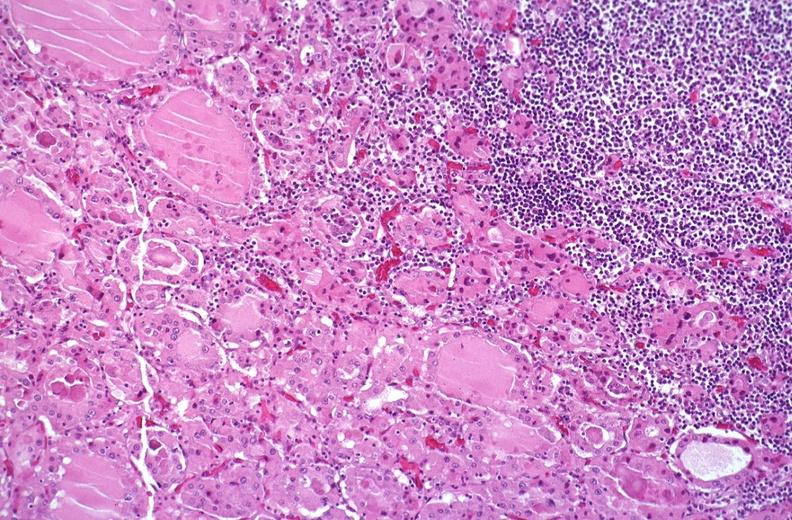what is present?
Answer the question using a single word or phrase. Endocrine 